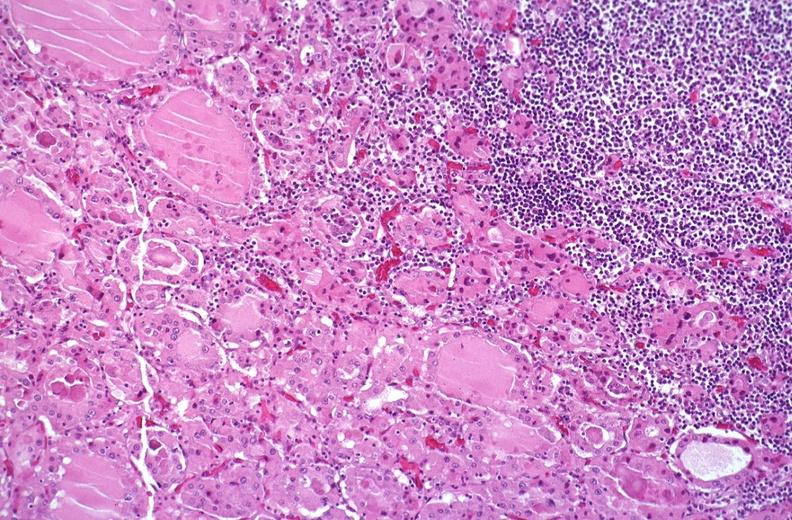what is present?
Answer the question using a single word or phrase. Endocrine 